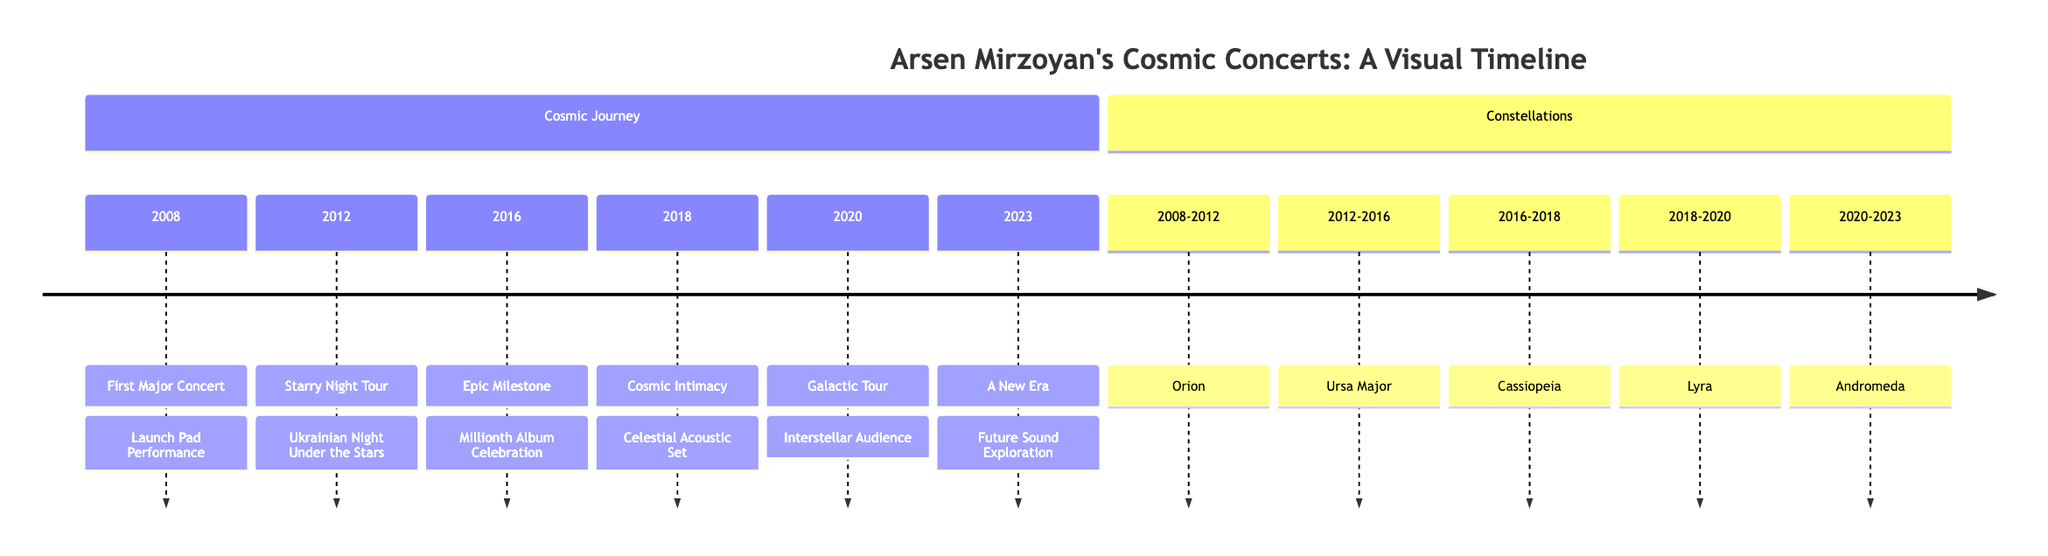What year did Arsen Mirzoyan have his first major concert? The timeline displays the first major concert in the year 2008.
Answer: 2008 What was the title of the 2016 milestone concert? According to the timeline, the title of the 2016 concert is “Millionth Album Celebration.”
Answer: Millionth Album Celebration How long did the Orion constellation represent concert dates? The diagram shows the Orion constellation covering the years from 2008 to 2012, which is a duration of 4 years.
Answer: 4 years Which constellation spans from 2016 to 2018? The timeline indicates that the Cassiopeia constellation covers these years.
Answer: Cassiopeia What is the theme of the concert in 2020? The timeline presents the 2020 concert under the theme “Galactic Tour.”
Answer: Galactic Tour How many major concerts are depicted before 2020? By reviewing the timeline, the concerts listed before 2020 are 5 in total, from 2008 to 2018.
Answer: 5 What is the total duration represented for the Andromeda constellation? The diagram shows the Andromeda constellation covering 3 years from 2020 to 2023.
Answer: 3 years Which concert corresponds to the period of the Lyra constellation? The timeline illustrates that the Cosmic Intimacy concert is under the Lyra constellation, occurring during 2018-2020.
Answer: Cosmic Intimacy How many sections are present in the diagram? The diagram has two main sections: “Cosmic Journey” and “Constellations.”
Answer: 2 